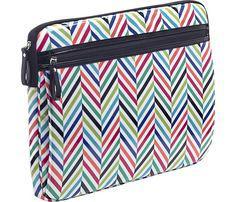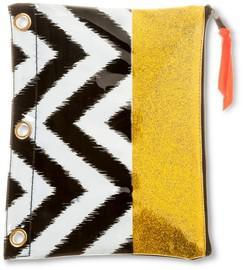The first image is the image on the left, the second image is the image on the right. Analyze the images presented: Is the assertion "for the image on the right side, the bag has black and white zigzags." valid? Answer yes or no. Yes. 